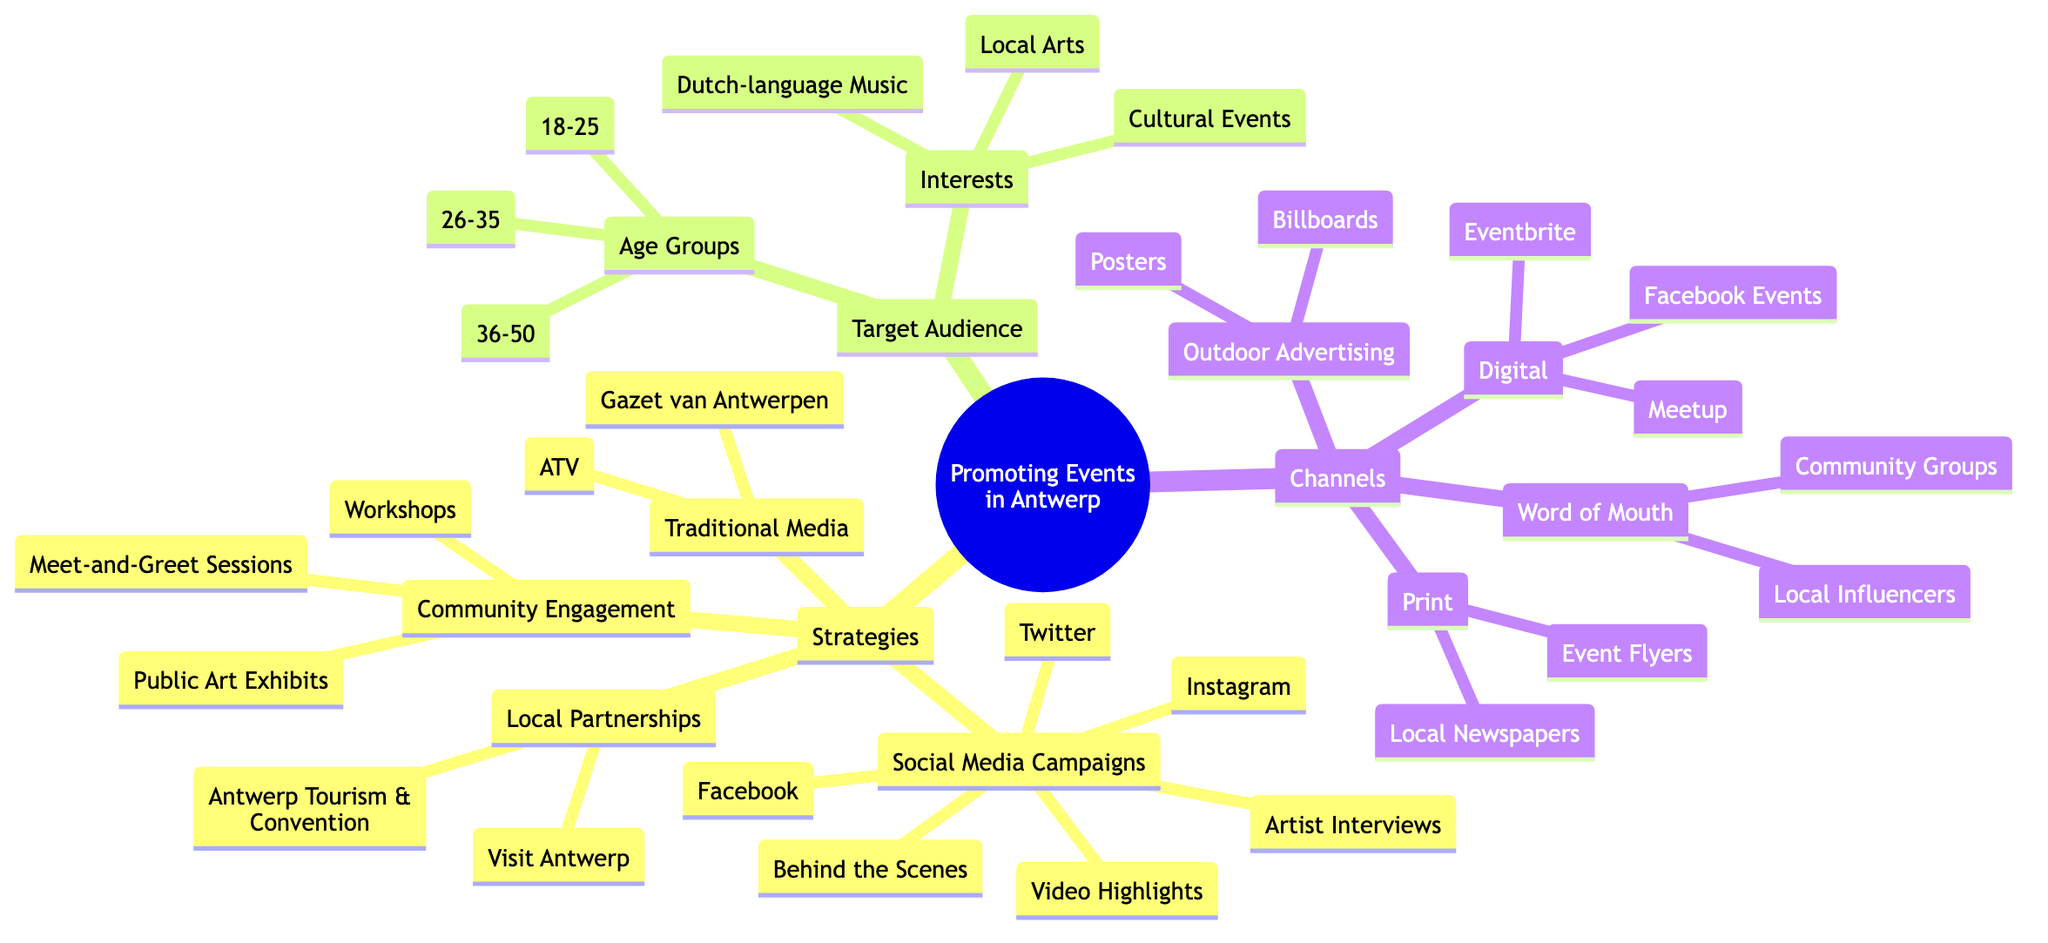What strategies are listed for promoting events? The strategies node has several branches that list specific strategies for promoting events. These branches include Social Media Campaigns, Local Partnerships, Community Engagement, and Traditional Media. These strategies provide a variety of methods to reach the target audience and promote events effectively.
Answer: Social Media Campaigns, Local Partnerships, Community Engagement, Traditional Media How many age groups are identified in the target audience? In the Target Audience section, there is a node labeled Age Groups that lists three specific age ranges: 18-25, 26-35, and 36-50. To find the answer, we simply count the items listed under this node.
Answer: 3 Which platforms are included in the Social Media Campaigns strategy? The Social Media Campaigns node branches out into specific platforms. By examining the sub-nodes under this strategy, we find that Facebook, Instagram, and Twitter are explicitly listed. Hence, these are the platforms used for marketing.
Answer: Facebook, Instagram, Twitter What type of content is emphasized in Social Media Campaigns? Within the Social Media Campaigns node, there are various content types listed that include Video Highlights, Artist Interviews, and Behind the Scenes. These content types are key in engaging the audience and promoting events effectively through social media.
Answer: Video Highlights, Artist Interviews, Behind the Scenes Which audiences are targeted based on interests? The Target Audience section lists several interests under a node titled Interests. When looking closely, we can see that the interests identified are Dutch-language Music, Local Arts, and Cultural Events. These interests help define the types of individuals likely to attend events.
Answer: Dutch-language Music, Local Arts, Cultural Events What are some channels mentioned under the Digital category? The Channels section of the mind map features a Digital category that includes Eventbrite, Meetup, and Facebook Events. By looking at this branch, we determine these specific digital platforms are suggested for promoting events.
Answer: Eventbrite, Meetup, Facebook Events What is one type of community engagement initiative listed? The Community Engagement node outlines various initiatives, such as Workshops, Meet-and-Greet Sessions, and Public Art Exhibits. By identifying the initiatives under this node, we can see the different ways to engage the community, with any of these serving as examples.
Answer: Workshops How many organizations are listed under Local Partnerships? The Local Partnerships node reveals two specific organizations: Visit Antwerp and Antwerp Tourism & Convention. Counting the items reveals a total of two organizations associated with this strategy.
Answer: 2 Which outdoor advertising methods are suggested? The Channels section includes an Outdoor Advertising category, which mentions Billboards and Posters. The reasoning involves locating the Outdoor Advertising node and identifying the methods listed under it.
Answer: Billboards, Posters 